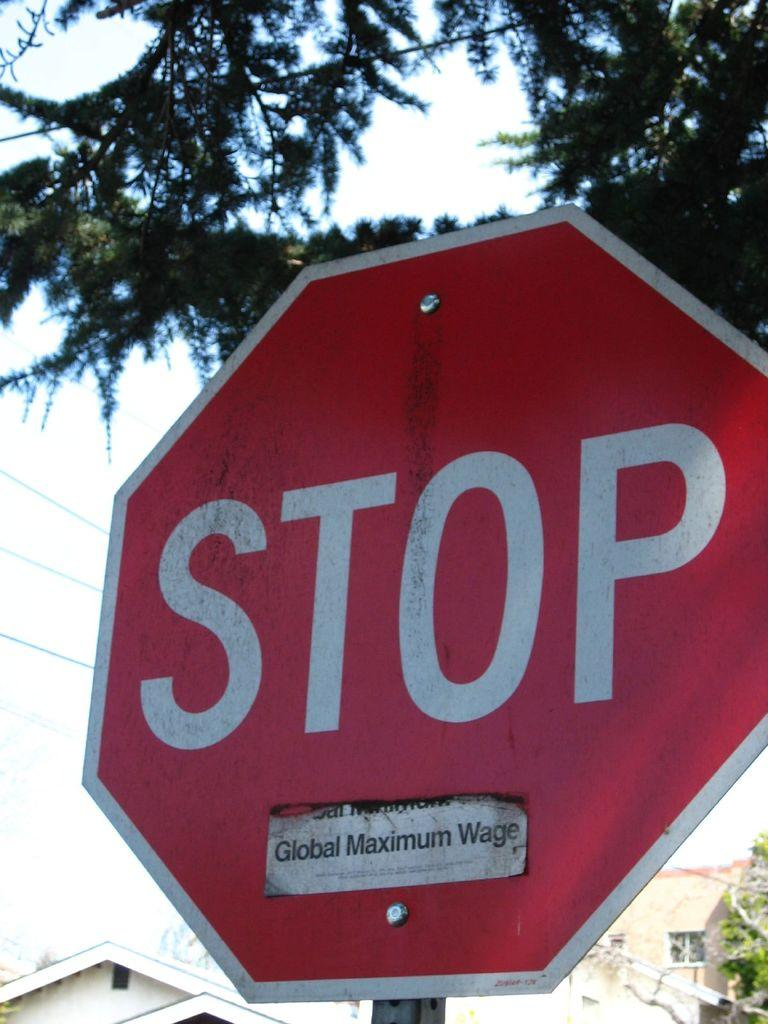Provide a one-sentence caption for the provided image. A stop sign with a global maximum wage sticker on it. 